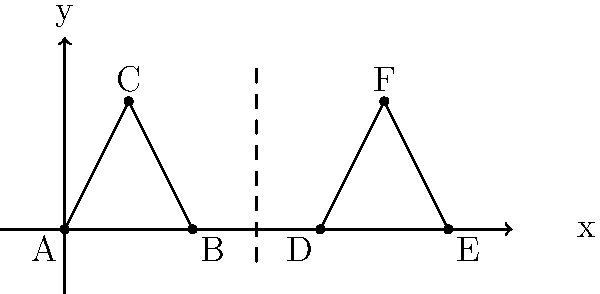A whistle-shaped triangle ABC undergoes a reflection across the line x = 3, followed by a translation of 4 units to the right. The resulting triangle is DEF. If the coordinates of point C are (1, 2), what are the coordinates of point F after the composite transformation? Let's approach this step-by-step:

1) First, we need to reflect triangle ABC across the line x = 3.
   - The x-coordinate of point C (1) is 2 units left of x = 3.
   - After reflection, it will be 2 units right of x = 3, so the x-coordinate becomes 5.
   - The y-coordinate remains unchanged at 2.
   - After reflection, C is at (5, 2).

2) Next, we translate the reflected triangle 4 units to the right.
   - This means we add 4 to the x-coordinate.
   - The x-coordinate changes from 5 to 9.
   - The y-coordinate remains unchanged.

3) Therefore, after the composite transformation:
   - Point C has been transformed to point F.
   - The coordinates of F are (9, 2).
Answer: (9, 2) 